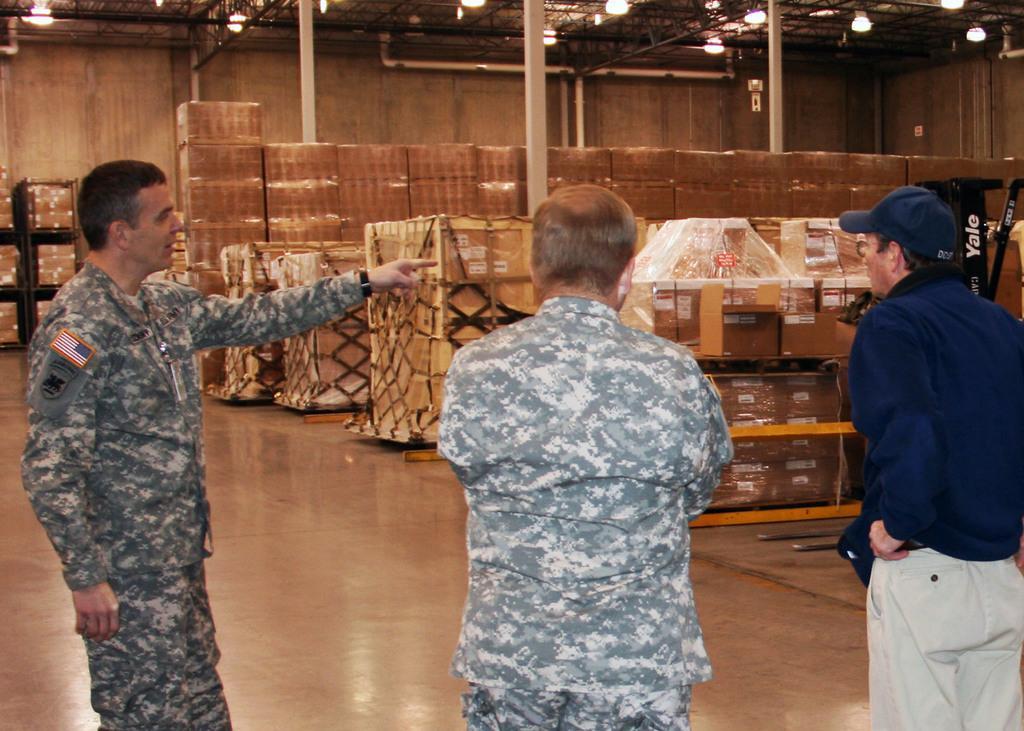Could you give a brief overview of what you see in this image? In this picture we can see three people standing on the floor. There are few boxes which are arranged in some racks. There are some lights on top. 